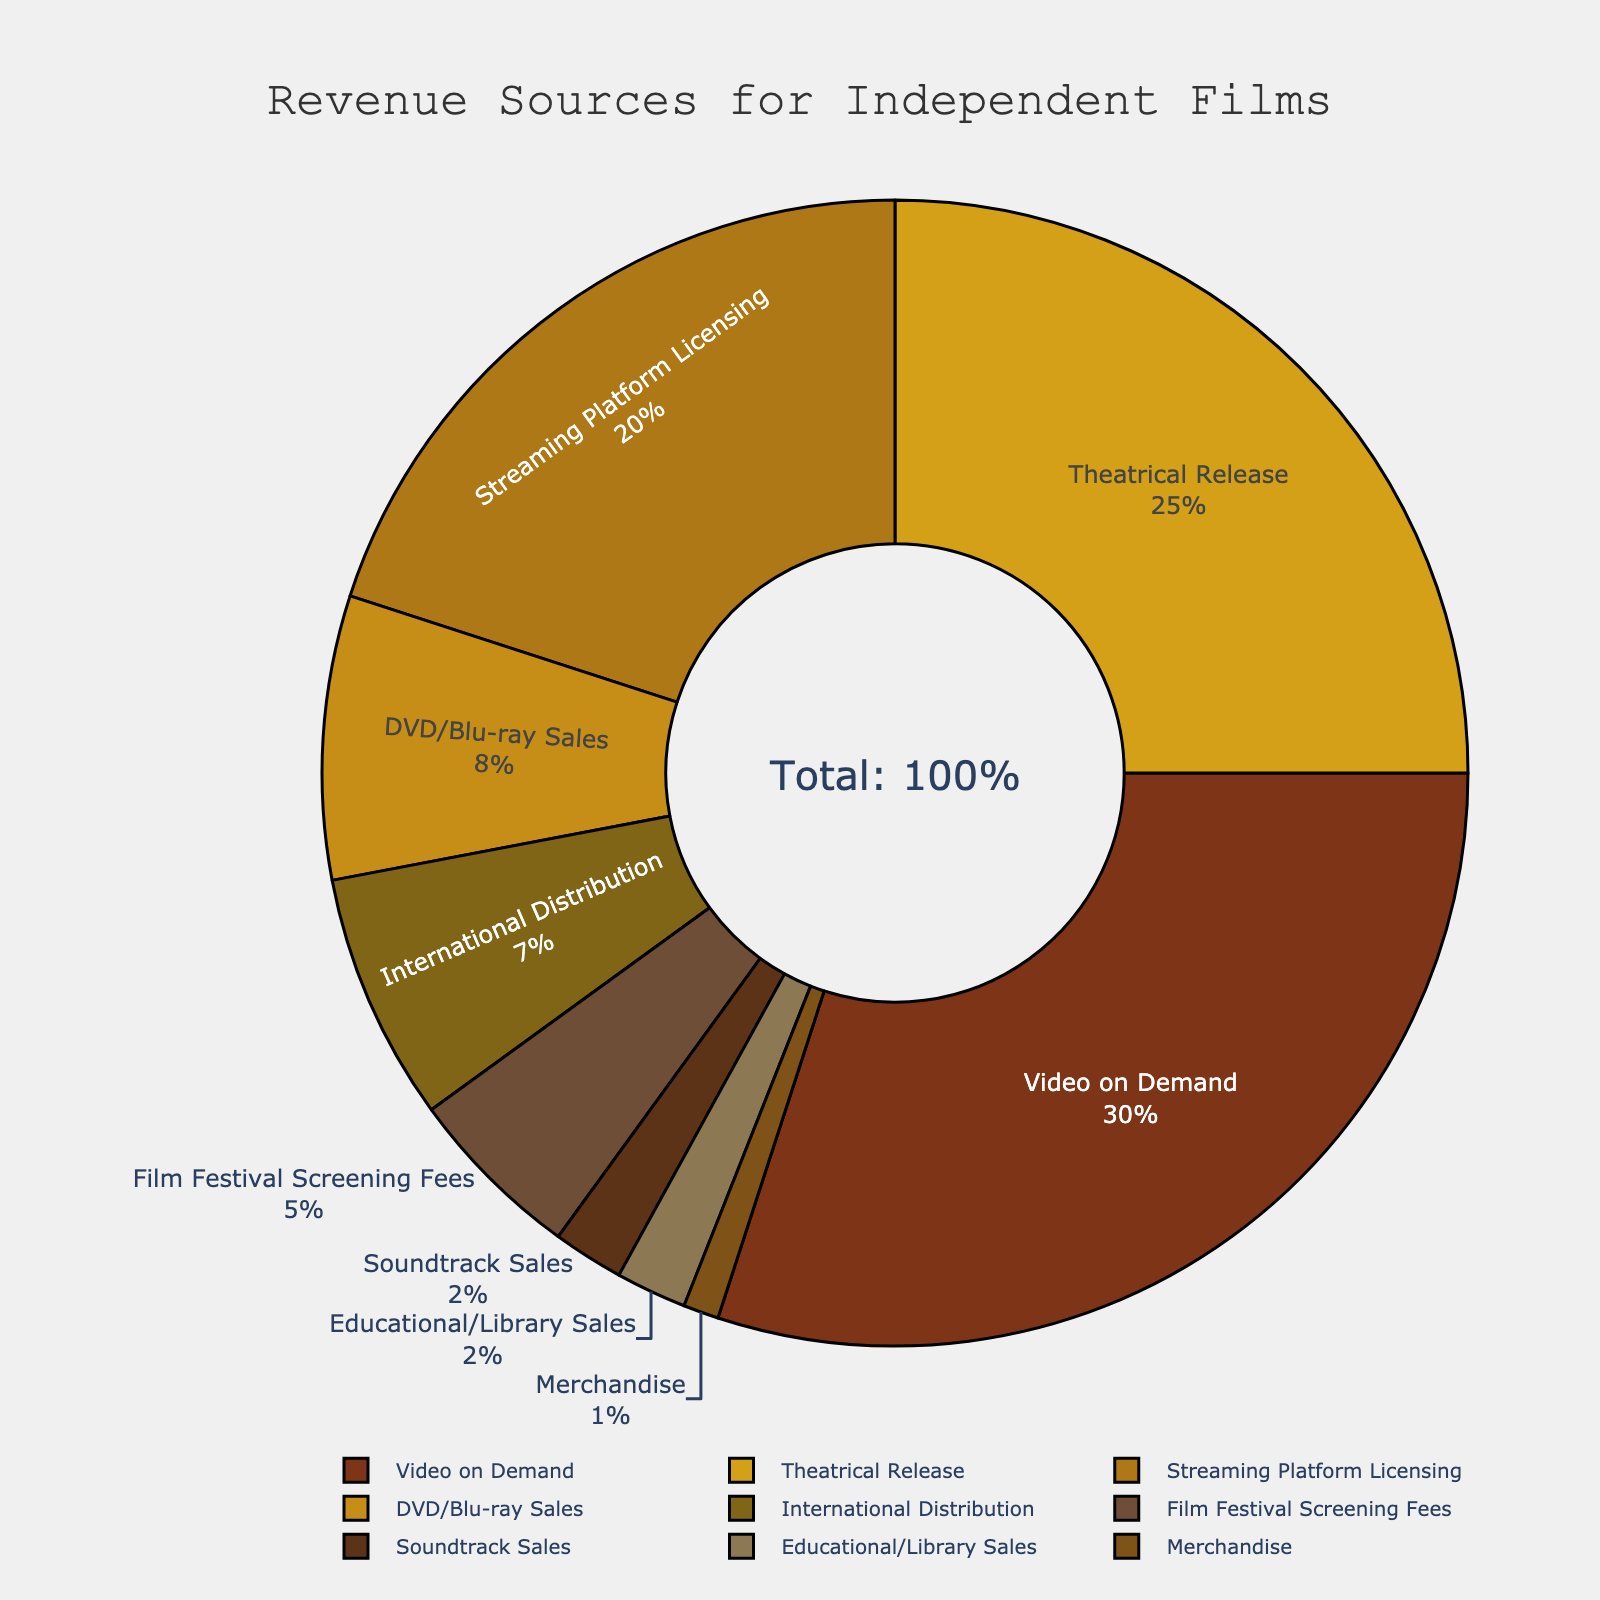Which revenue source contributes the most to independent films? The visual data in the figure shows the percentage breakdown of various revenue sources, and by examining the pie chart, one can see that Video on Demand has the largest segment with 30%.
Answer: Video on Demand Which two revenue sources together contribute the highest percentage to independent films? By examining the figure, Video on Demand (30%) and Theatrical Release (25%) represent the largest segments. Summing them up, 30% + 25% = 55%.
Answer: Video on Demand and Theatrical Release How does the percentage for DVD/Blu-ray Sales compare to that for Streaming Platform Licensing? From the figure, DVD/Blu-ray Sales contribute 8% while Streaming Platform Licensing contributes 20%. This shows Streaming Platform Licensing has a larger portion compared to DVD/Blu-ray Sales by 12%.
Answer: Streaming Platform Licensing is 12% higher Which three sources have the smallest contributions, and what is their combined percentage? The three smallest segments in the pie chart are Merchandise (1%), Soundtrack Sales (2%), and Educational/Library Sales (2%). Their combined percentage is 1% + 2% + 2% = 5%.
Answer: Merchandise, Soundtrack Sales, and Educational/Library Sales; 5% How much more does Video on Demand contribute compared to International Distribution? According to the figure, Video on Demand contributes 30% while International Distribution contributes 7%. Therefore, Video on Demand contributes 30% - 7% = 23% more.
Answer: 23% more What's the total percentage contributed by all the sources related to distribution (Theatrical Release, International Distribution, and Streaming Platform Licensing)? Adding the percentages for Theatrical Release (25%), International Distribution (7%), and Streaming Platform Licensing (20%) gives 25% + 7% + 20% = 52%.
Answer: 52% Is the percentage of revenue from Film Festival Screening Fees greater than or less than that from Soundtrack Sales? Film Festival Screening Fees are 5% and Soundtrack Sales are 2%, according to the pie chart. This indicates Film Festival Screening Fees are greater.
Answer: Greater Which revenue source(s) contribute exactly twice as much as Soundtrack Sales? According to the figure, Soundtrack Sales contribute 2% and Educational/Library Sales also contribute 2%, but Video on Demand contributes 4%. Thus, no sources contribute exactly twice as much.
Answer: None 